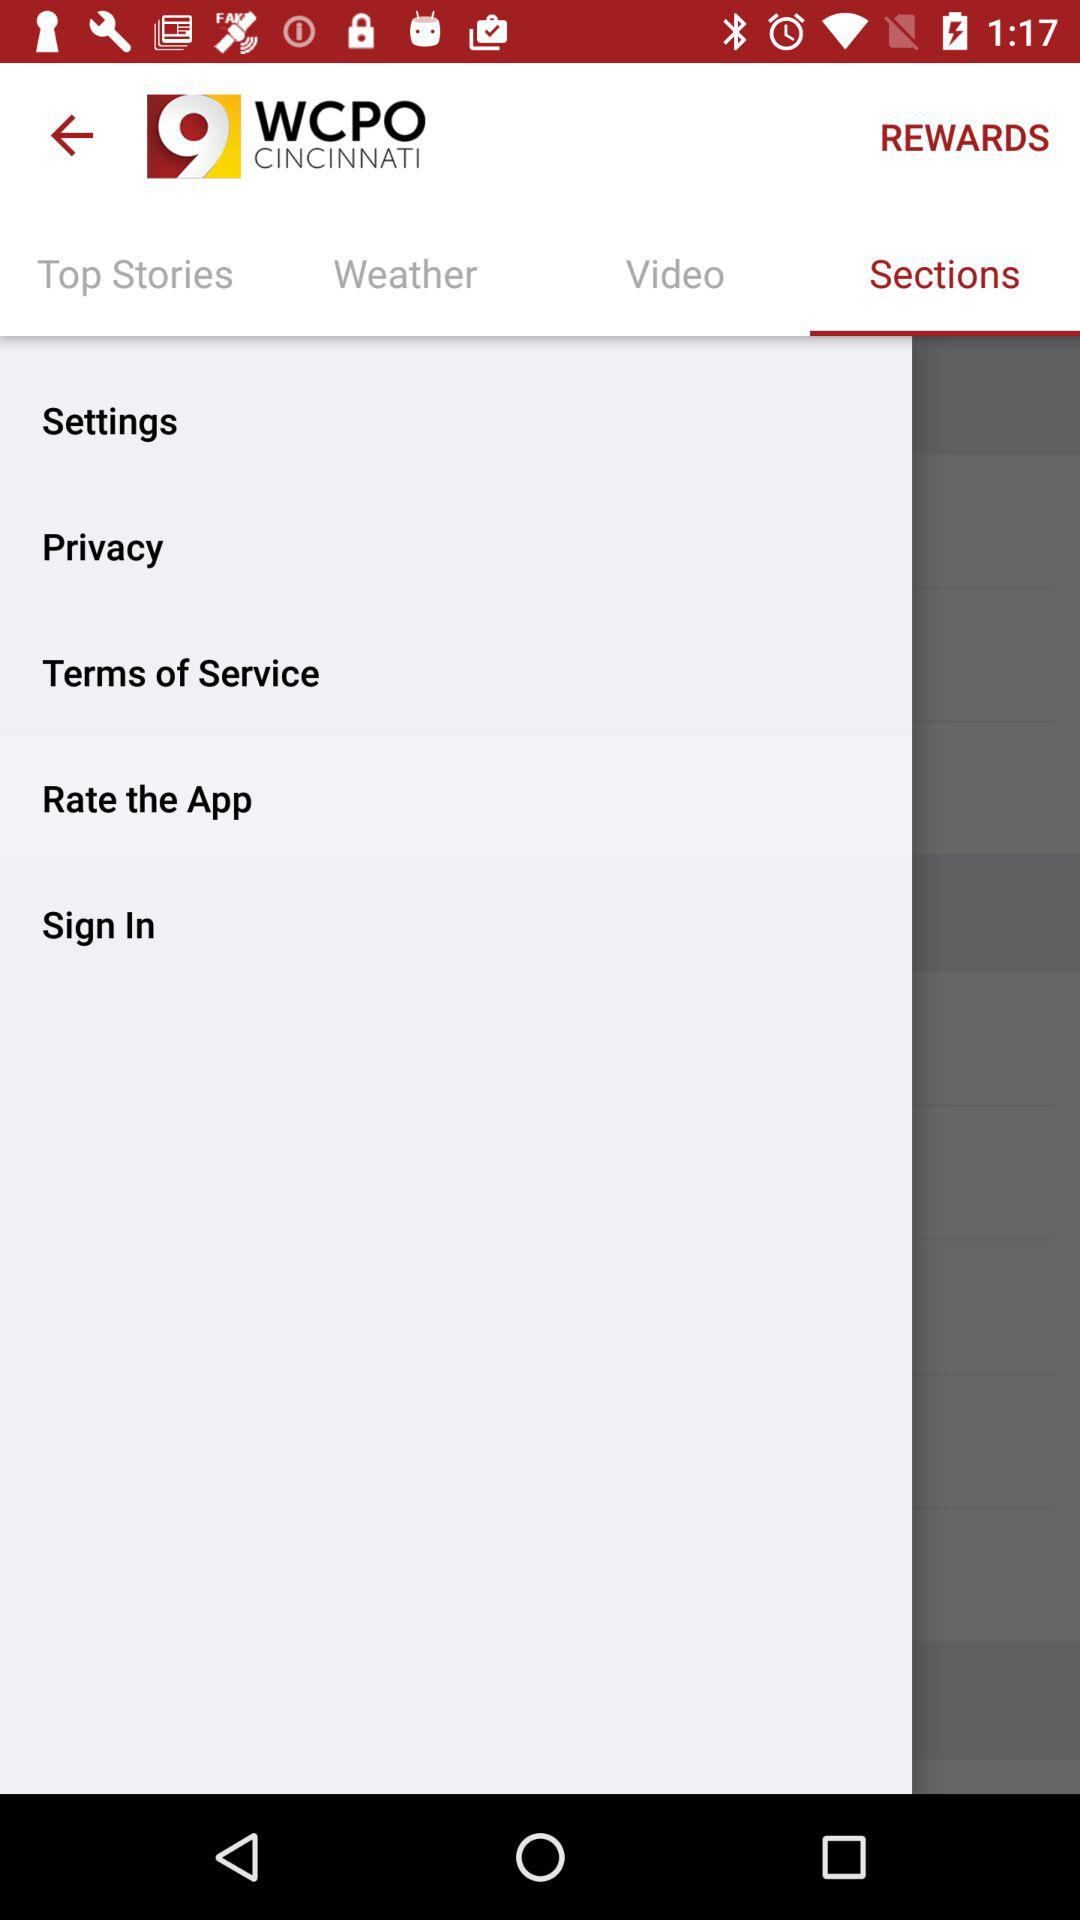What is the name of the application? The name of the application is "WCPO CINCINNATI". 